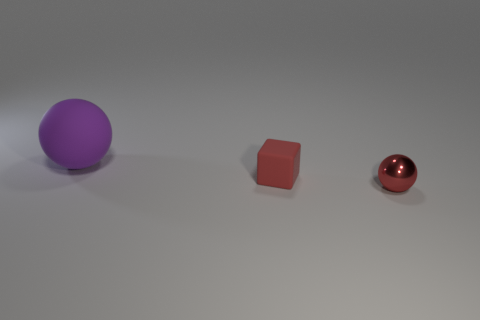Add 3 tiny spheres. How many objects exist? 6 Subtract all cubes. How many objects are left? 2 Add 1 gray metallic cylinders. How many gray metallic cylinders exist? 1 Subtract 0 blue cubes. How many objects are left? 3 Subtract all yellow objects. Subtract all matte things. How many objects are left? 1 Add 1 large matte things. How many large matte things are left? 2 